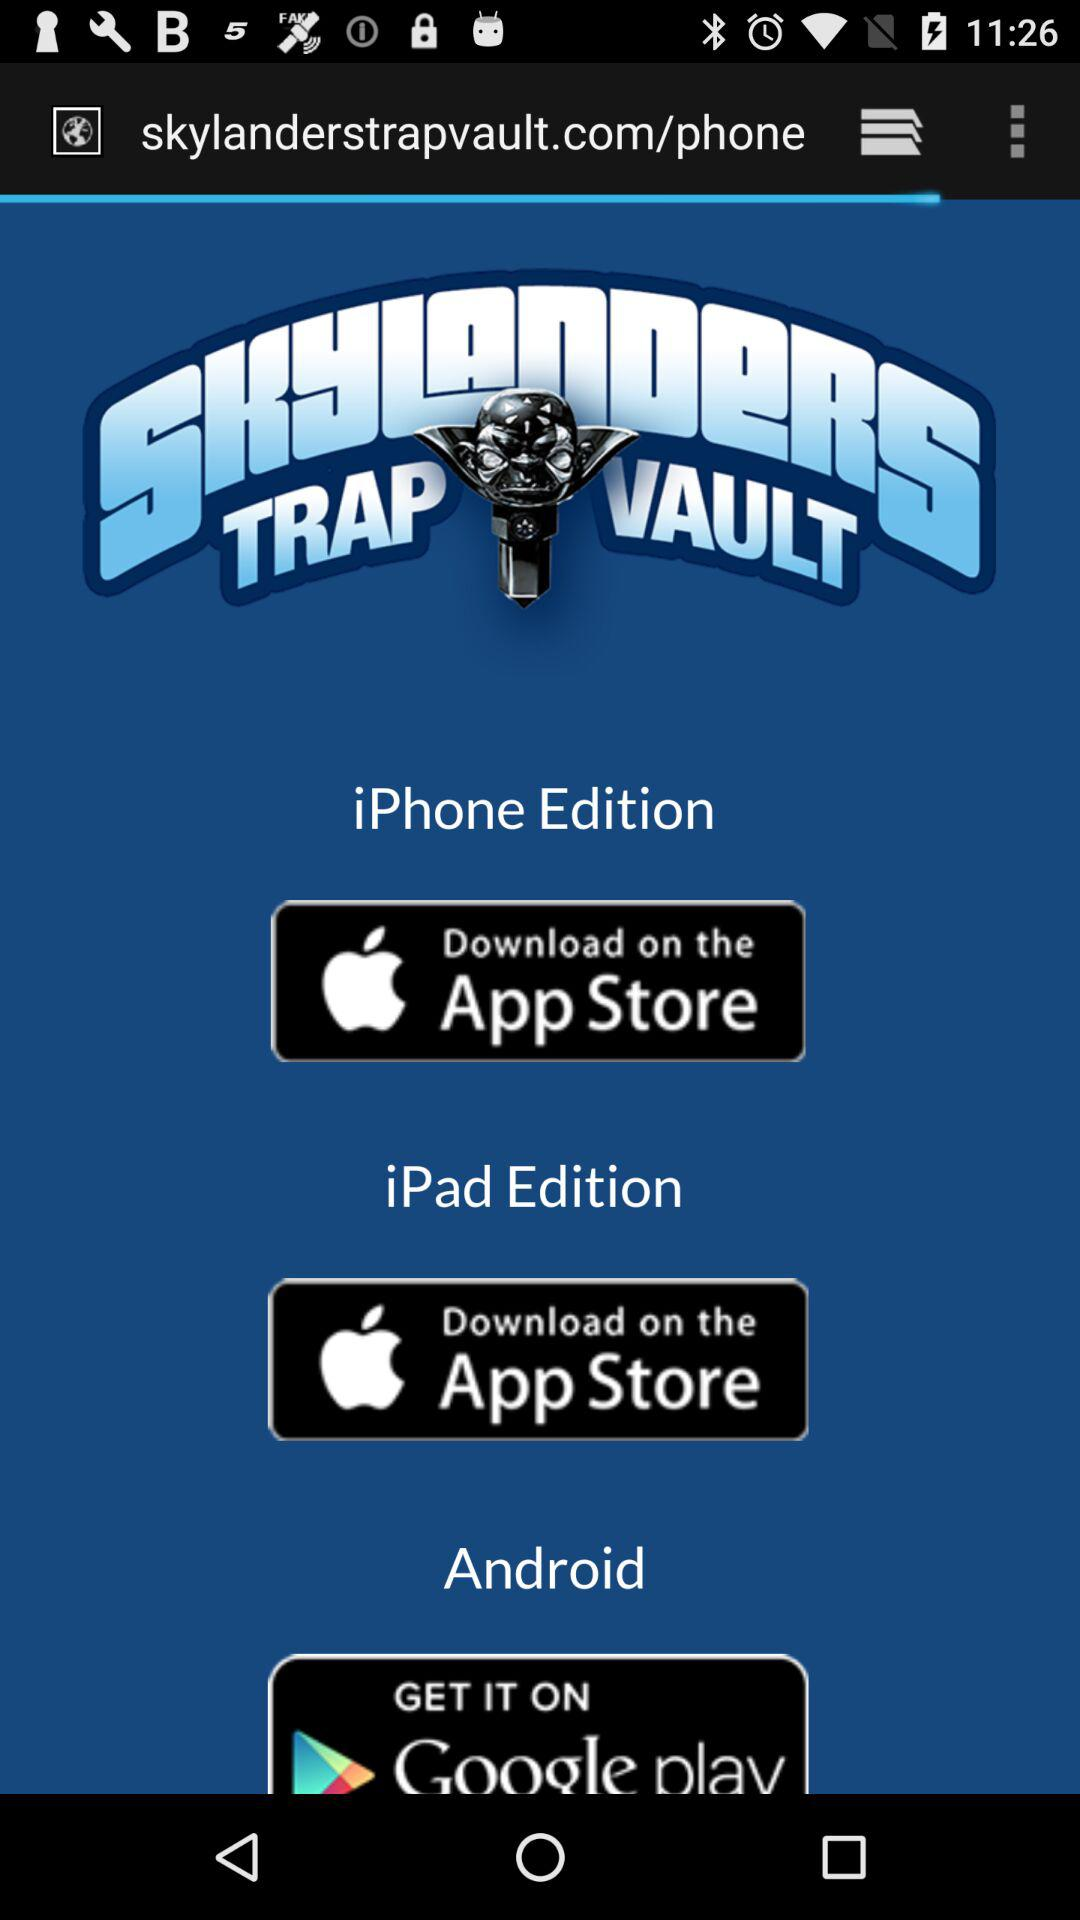How many editions of Skylanders Trap Vault are available?
Answer the question using a single word or phrase. 3 